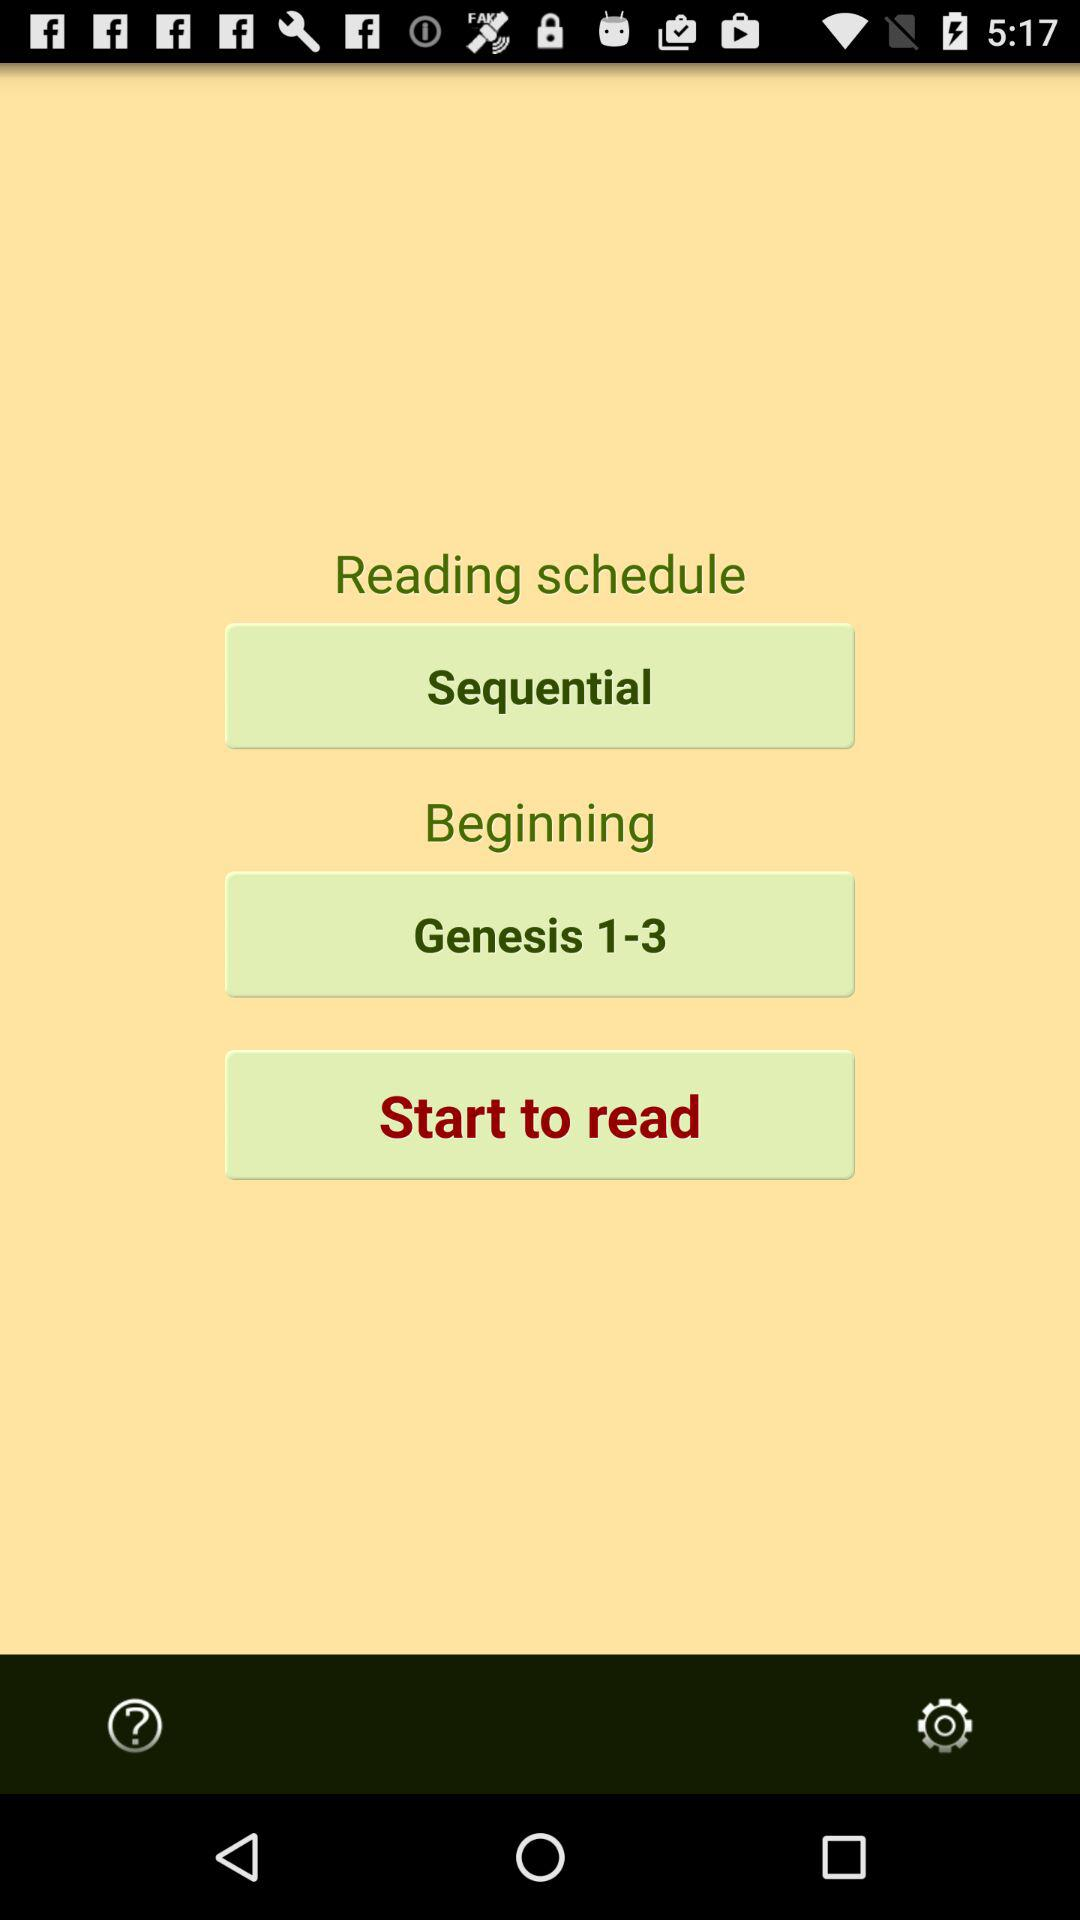What's the Reading Schedule Form?
When the provided information is insufficient, respond with <no answer>. <no answer> 